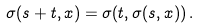<formula> <loc_0><loc_0><loc_500><loc_500>\sigma ( s + t , x ) = \sigma ( t , \sigma ( s , x ) ) \, .</formula> 